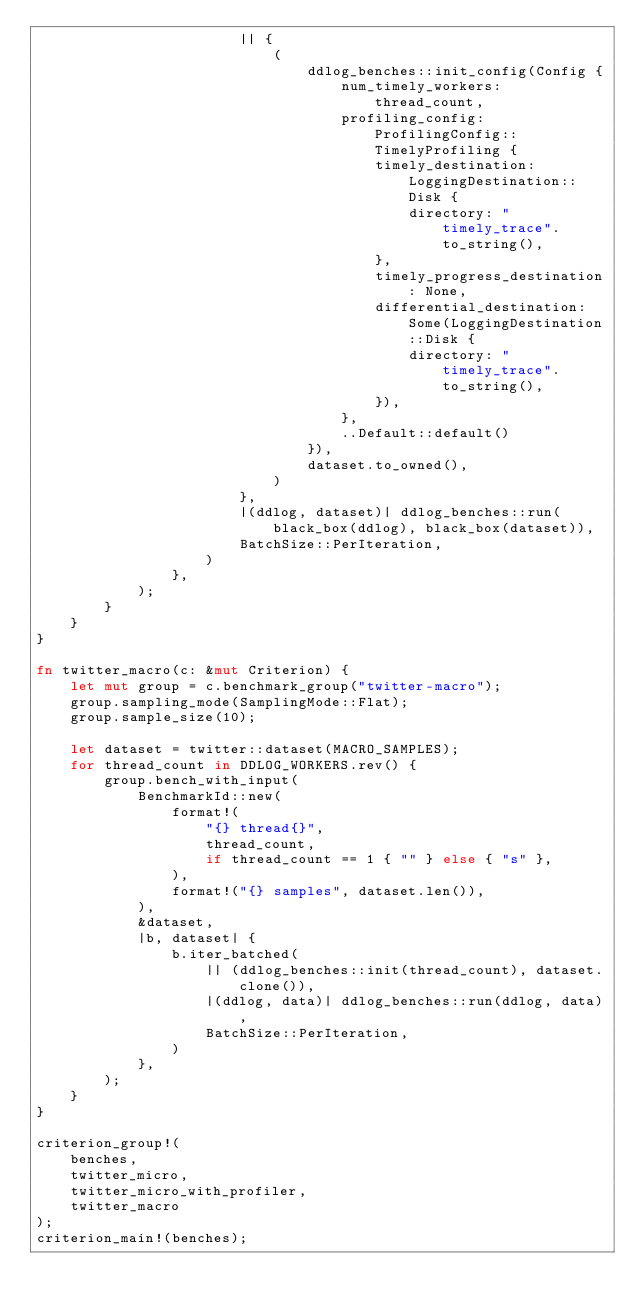Convert code to text. <code><loc_0><loc_0><loc_500><loc_500><_Rust_>                        || {
                            (
                                ddlog_benches::init_config(Config {
                                    num_timely_workers: thread_count,
                                    profiling_config: ProfilingConfig::TimelyProfiling {
                                        timely_destination: LoggingDestination::Disk {
                                            directory: "timely_trace".to_string(),
                                        },
                                        timely_progress_destination: None,
                                        differential_destination: Some(LoggingDestination::Disk {
                                            directory: "timely_trace".to_string(),
                                        }),
                                    },
                                    ..Default::default()
                                }),
                                dataset.to_owned(),
                            )
                        },
                        |(ddlog, dataset)| ddlog_benches::run(black_box(ddlog), black_box(dataset)),
                        BatchSize::PerIteration,
                    )
                },
            );
        }
    }
}

fn twitter_macro(c: &mut Criterion) {
    let mut group = c.benchmark_group("twitter-macro");
    group.sampling_mode(SamplingMode::Flat);
    group.sample_size(10);

    let dataset = twitter::dataset(MACRO_SAMPLES);
    for thread_count in DDLOG_WORKERS.rev() {
        group.bench_with_input(
            BenchmarkId::new(
                format!(
                    "{} thread{}",
                    thread_count,
                    if thread_count == 1 { "" } else { "s" },
                ),
                format!("{} samples", dataset.len()),
            ),
            &dataset,
            |b, dataset| {
                b.iter_batched(
                    || (ddlog_benches::init(thread_count), dataset.clone()),
                    |(ddlog, data)| ddlog_benches::run(ddlog, data),
                    BatchSize::PerIteration,
                )
            },
        );
    }
}

criterion_group!(
    benches,
    twitter_micro,
    twitter_micro_with_profiler,
    twitter_macro
);
criterion_main!(benches);
</code> 